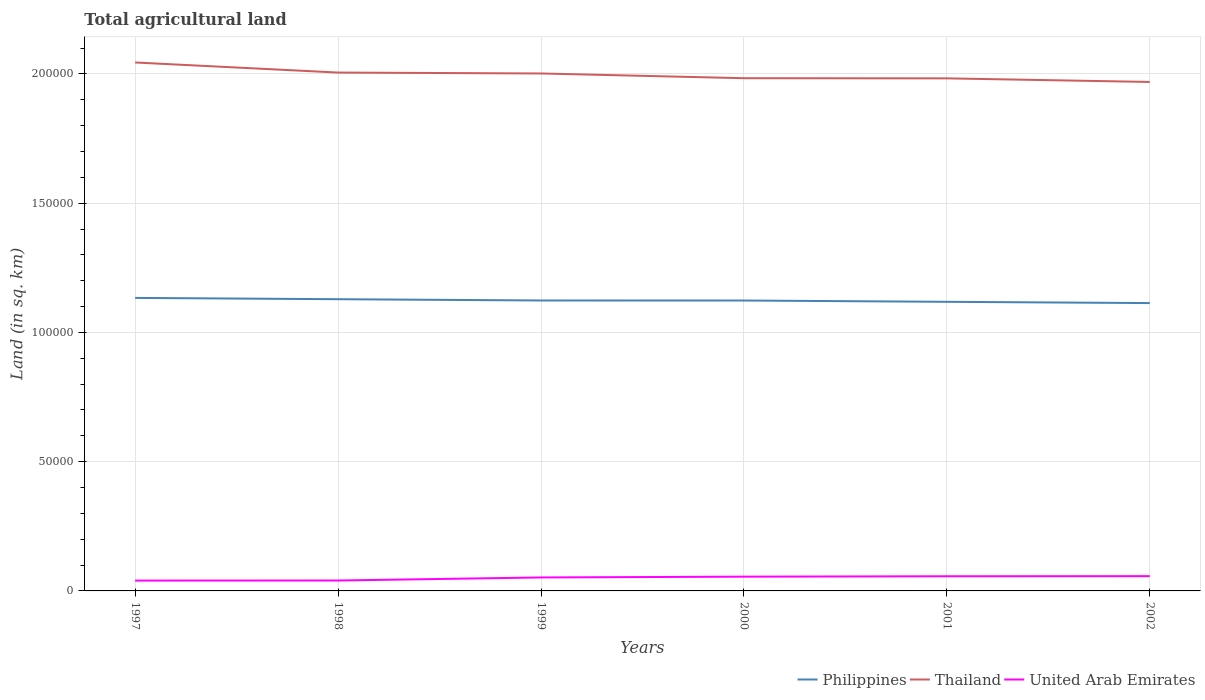How many different coloured lines are there?
Your response must be concise. 3. Does the line corresponding to Thailand intersect with the line corresponding to Philippines?
Provide a short and direct response. No. Across all years, what is the maximum total agricultural land in United Arab Emirates?
Keep it short and to the point. 4000. In which year was the total agricultural land in Thailand maximum?
Keep it short and to the point. 2002. What is the total total agricultural land in Philippines in the graph?
Keep it short and to the point. 10. What is the difference between the highest and the second highest total agricultural land in Thailand?
Offer a very short reply. 7530. What is the difference between the highest and the lowest total agricultural land in United Arab Emirates?
Offer a terse response. 4. Does the graph contain grids?
Ensure brevity in your answer.  Yes. How are the legend labels stacked?
Give a very brief answer. Horizontal. What is the title of the graph?
Provide a succinct answer. Total agricultural land. Does "Uganda" appear as one of the legend labels in the graph?
Give a very brief answer. No. What is the label or title of the X-axis?
Keep it short and to the point. Years. What is the label or title of the Y-axis?
Your answer should be very brief. Land (in sq. km). What is the Land (in sq. km) of Philippines in 1997?
Offer a terse response. 1.13e+05. What is the Land (in sq. km) of Thailand in 1997?
Your response must be concise. 2.04e+05. What is the Land (in sq. km) in United Arab Emirates in 1997?
Ensure brevity in your answer.  4000. What is the Land (in sq. km) in Philippines in 1998?
Make the answer very short. 1.13e+05. What is the Land (in sq. km) of Thailand in 1998?
Provide a short and direct response. 2.01e+05. What is the Land (in sq. km) in United Arab Emirates in 1998?
Keep it short and to the point. 4030. What is the Land (in sq. km) of Philippines in 1999?
Give a very brief answer. 1.12e+05. What is the Land (in sq. km) in Thailand in 1999?
Make the answer very short. 2.00e+05. What is the Land (in sq. km) of United Arab Emirates in 1999?
Offer a terse response. 5210. What is the Land (in sq. km) of Philippines in 2000?
Make the answer very short. 1.12e+05. What is the Land (in sq. km) in Thailand in 2000?
Ensure brevity in your answer.  1.98e+05. What is the Land (in sq. km) of United Arab Emirates in 2000?
Give a very brief answer. 5520. What is the Land (in sq. km) of Philippines in 2001?
Your response must be concise. 1.12e+05. What is the Land (in sq. km) of Thailand in 2001?
Make the answer very short. 1.98e+05. What is the Land (in sq. km) in United Arab Emirates in 2001?
Give a very brief answer. 5670. What is the Land (in sq. km) in Philippines in 2002?
Your answer should be very brief. 1.11e+05. What is the Land (in sq. km) in Thailand in 2002?
Keep it short and to the point. 1.97e+05. What is the Land (in sq. km) in United Arab Emirates in 2002?
Offer a very short reply. 5710. Across all years, what is the maximum Land (in sq. km) in Philippines?
Offer a very short reply. 1.13e+05. Across all years, what is the maximum Land (in sq. km) in Thailand?
Provide a succinct answer. 2.04e+05. Across all years, what is the maximum Land (in sq. km) in United Arab Emirates?
Keep it short and to the point. 5710. Across all years, what is the minimum Land (in sq. km) of Philippines?
Provide a short and direct response. 1.11e+05. Across all years, what is the minimum Land (in sq. km) in Thailand?
Your answer should be compact. 1.97e+05. Across all years, what is the minimum Land (in sq. km) in United Arab Emirates?
Offer a very short reply. 4000. What is the total Land (in sq. km) of Philippines in the graph?
Ensure brevity in your answer.  6.74e+05. What is the total Land (in sq. km) in Thailand in the graph?
Provide a succinct answer. 1.20e+06. What is the total Land (in sq. km) in United Arab Emirates in the graph?
Ensure brevity in your answer.  3.01e+04. What is the difference between the Land (in sq. km) of Philippines in 1997 and that in 1998?
Provide a short and direct response. 500. What is the difference between the Land (in sq. km) in Thailand in 1997 and that in 1998?
Offer a very short reply. 3900. What is the difference between the Land (in sq. km) of United Arab Emirates in 1997 and that in 1998?
Give a very brief answer. -30. What is the difference between the Land (in sq. km) of Thailand in 1997 and that in 1999?
Your answer should be compact. 4250. What is the difference between the Land (in sq. km) of United Arab Emirates in 1997 and that in 1999?
Give a very brief answer. -1210. What is the difference between the Land (in sq. km) of Philippines in 1997 and that in 2000?
Offer a very short reply. 1010. What is the difference between the Land (in sq. km) of Thailand in 1997 and that in 2000?
Offer a very short reply. 6080. What is the difference between the Land (in sq. km) in United Arab Emirates in 1997 and that in 2000?
Make the answer very short. -1520. What is the difference between the Land (in sq. km) of Philippines in 1997 and that in 2001?
Give a very brief answer. 1510. What is the difference between the Land (in sq. km) of Thailand in 1997 and that in 2001?
Provide a short and direct response. 6140. What is the difference between the Land (in sq. km) in United Arab Emirates in 1997 and that in 2001?
Offer a very short reply. -1670. What is the difference between the Land (in sq. km) of Thailand in 1997 and that in 2002?
Your answer should be compact. 7530. What is the difference between the Land (in sq. km) in United Arab Emirates in 1997 and that in 2002?
Offer a very short reply. -1710. What is the difference between the Land (in sq. km) in Thailand in 1998 and that in 1999?
Offer a terse response. 350. What is the difference between the Land (in sq. km) of United Arab Emirates in 1998 and that in 1999?
Keep it short and to the point. -1180. What is the difference between the Land (in sq. km) of Philippines in 1998 and that in 2000?
Ensure brevity in your answer.  510. What is the difference between the Land (in sq. km) of Thailand in 1998 and that in 2000?
Ensure brevity in your answer.  2180. What is the difference between the Land (in sq. km) of United Arab Emirates in 1998 and that in 2000?
Offer a very short reply. -1490. What is the difference between the Land (in sq. km) of Philippines in 1998 and that in 2001?
Provide a short and direct response. 1010. What is the difference between the Land (in sq. km) of Thailand in 1998 and that in 2001?
Your answer should be compact. 2240. What is the difference between the Land (in sq. km) of United Arab Emirates in 1998 and that in 2001?
Offer a very short reply. -1640. What is the difference between the Land (in sq. km) in Philippines in 1998 and that in 2002?
Your answer should be very brief. 1500. What is the difference between the Land (in sq. km) of Thailand in 1998 and that in 2002?
Offer a very short reply. 3630. What is the difference between the Land (in sq. km) of United Arab Emirates in 1998 and that in 2002?
Your response must be concise. -1680. What is the difference between the Land (in sq. km) in Thailand in 1999 and that in 2000?
Provide a short and direct response. 1830. What is the difference between the Land (in sq. km) of United Arab Emirates in 1999 and that in 2000?
Keep it short and to the point. -310. What is the difference between the Land (in sq. km) of Philippines in 1999 and that in 2001?
Your answer should be very brief. 510. What is the difference between the Land (in sq. km) in Thailand in 1999 and that in 2001?
Give a very brief answer. 1890. What is the difference between the Land (in sq. km) in United Arab Emirates in 1999 and that in 2001?
Offer a terse response. -460. What is the difference between the Land (in sq. km) of Philippines in 1999 and that in 2002?
Your response must be concise. 1000. What is the difference between the Land (in sq. km) of Thailand in 1999 and that in 2002?
Provide a short and direct response. 3280. What is the difference between the Land (in sq. km) of United Arab Emirates in 1999 and that in 2002?
Give a very brief answer. -500. What is the difference between the Land (in sq. km) in Philippines in 2000 and that in 2001?
Your response must be concise. 500. What is the difference between the Land (in sq. km) in United Arab Emirates in 2000 and that in 2001?
Your answer should be very brief. -150. What is the difference between the Land (in sq. km) of Philippines in 2000 and that in 2002?
Offer a very short reply. 990. What is the difference between the Land (in sq. km) of Thailand in 2000 and that in 2002?
Provide a succinct answer. 1450. What is the difference between the Land (in sq. km) of United Arab Emirates in 2000 and that in 2002?
Give a very brief answer. -190. What is the difference between the Land (in sq. km) of Philippines in 2001 and that in 2002?
Provide a succinct answer. 490. What is the difference between the Land (in sq. km) in Thailand in 2001 and that in 2002?
Give a very brief answer. 1390. What is the difference between the Land (in sq. km) of Philippines in 1997 and the Land (in sq. km) of Thailand in 1998?
Offer a very short reply. -8.72e+04. What is the difference between the Land (in sq. km) in Philippines in 1997 and the Land (in sq. km) in United Arab Emirates in 1998?
Offer a very short reply. 1.09e+05. What is the difference between the Land (in sq. km) in Thailand in 1997 and the Land (in sq. km) in United Arab Emirates in 1998?
Your answer should be compact. 2.00e+05. What is the difference between the Land (in sq. km) in Philippines in 1997 and the Land (in sq. km) in Thailand in 1999?
Give a very brief answer. -8.68e+04. What is the difference between the Land (in sq. km) of Philippines in 1997 and the Land (in sq. km) of United Arab Emirates in 1999?
Give a very brief answer. 1.08e+05. What is the difference between the Land (in sq. km) in Thailand in 1997 and the Land (in sq. km) in United Arab Emirates in 1999?
Keep it short and to the point. 1.99e+05. What is the difference between the Land (in sq. km) of Philippines in 1997 and the Land (in sq. km) of Thailand in 2000?
Give a very brief answer. -8.50e+04. What is the difference between the Land (in sq. km) of Philippines in 1997 and the Land (in sq. km) of United Arab Emirates in 2000?
Offer a very short reply. 1.08e+05. What is the difference between the Land (in sq. km) in Thailand in 1997 and the Land (in sq. km) in United Arab Emirates in 2000?
Your answer should be very brief. 1.99e+05. What is the difference between the Land (in sq. km) of Philippines in 1997 and the Land (in sq. km) of Thailand in 2001?
Make the answer very short. -8.49e+04. What is the difference between the Land (in sq. km) in Philippines in 1997 and the Land (in sq. km) in United Arab Emirates in 2001?
Make the answer very short. 1.08e+05. What is the difference between the Land (in sq. km) of Thailand in 1997 and the Land (in sq. km) of United Arab Emirates in 2001?
Offer a very short reply. 1.99e+05. What is the difference between the Land (in sq. km) in Philippines in 1997 and the Land (in sq. km) in Thailand in 2002?
Ensure brevity in your answer.  -8.35e+04. What is the difference between the Land (in sq. km) in Philippines in 1997 and the Land (in sq. km) in United Arab Emirates in 2002?
Offer a very short reply. 1.08e+05. What is the difference between the Land (in sq. km) in Thailand in 1997 and the Land (in sq. km) in United Arab Emirates in 2002?
Provide a succinct answer. 1.99e+05. What is the difference between the Land (in sq. km) of Philippines in 1998 and the Land (in sq. km) of Thailand in 1999?
Offer a very short reply. -8.73e+04. What is the difference between the Land (in sq. km) in Philippines in 1998 and the Land (in sq. km) in United Arab Emirates in 1999?
Your answer should be very brief. 1.08e+05. What is the difference between the Land (in sq. km) in Thailand in 1998 and the Land (in sq. km) in United Arab Emirates in 1999?
Provide a short and direct response. 1.95e+05. What is the difference between the Land (in sq. km) in Philippines in 1998 and the Land (in sq. km) in Thailand in 2000?
Make the answer very short. -8.55e+04. What is the difference between the Land (in sq. km) in Philippines in 1998 and the Land (in sq. km) in United Arab Emirates in 2000?
Your answer should be compact. 1.07e+05. What is the difference between the Land (in sq. km) in Thailand in 1998 and the Land (in sq. km) in United Arab Emirates in 2000?
Make the answer very short. 1.95e+05. What is the difference between the Land (in sq. km) of Philippines in 1998 and the Land (in sq. km) of Thailand in 2001?
Your answer should be compact. -8.54e+04. What is the difference between the Land (in sq. km) in Philippines in 1998 and the Land (in sq. km) in United Arab Emirates in 2001?
Give a very brief answer. 1.07e+05. What is the difference between the Land (in sq. km) in Thailand in 1998 and the Land (in sq. km) in United Arab Emirates in 2001?
Your response must be concise. 1.95e+05. What is the difference between the Land (in sq. km) in Philippines in 1998 and the Land (in sq. km) in Thailand in 2002?
Your response must be concise. -8.40e+04. What is the difference between the Land (in sq. km) in Philippines in 1998 and the Land (in sq. km) in United Arab Emirates in 2002?
Offer a very short reply. 1.07e+05. What is the difference between the Land (in sq. km) of Thailand in 1998 and the Land (in sq. km) of United Arab Emirates in 2002?
Your answer should be compact. 1.95e+05. What is the difference between the Land (in sq. km) in Philippines in 1999 and the Land (in sq. km) in Thailand in 2000?
Give a very brief answer. -8.60e+04. What is the difference between the Land (in sq. km) of Philippines in 1999 and the Land (in sq. km) of United Arab Emirates in 2000?
Offer a very short reply. 1.07e+05. What is the difference between the Land (in sq. km) of Thailand in 1999 and the Land (in sq. km) of United Arab Emirates in 2000?
Provide a succinct answer. 1.95e+05. What is the difference between the Land (in sq. km) in Philippines in 1999 and the Land (in sq. km) in Thailand in 2001?
Provide a succinct answer. -8.59e+04. What is the difference between the Land (in sq. km) of Philippines in 1999 and the Land (in sq. km) of United Arab Emirates in 2001?
Give a very brief answer. 1.07e+05. What is the difference between the Land (in sq. km) in Thailand in 1999 and the Land (in sq. km) in United Arab Emirates in 2001?
Provide a succinct answer. 1.94e+05. What is the difference between the Land (in sq. km) in Philippines in 1999 and the Land (in sq. km) in Thailand in 2002?
Your response must be concise. -8.45e+04. What is the difference between the Land (in sq. km) in Philippines in 1999 and the Land (in sq. km) in United Arab Emirates in 2002?
Keep it short and to the point. 1.07e+05. What is the difference between the Land (in sq. km) of Thailand in 1999 and the Land (in sq. km) of United Arab Emirates in 2002?
Keep it short and to the point. 1.94e+05. What is the difference between the Land (in sq. km) of Philippines in 2000 and the Land (in sq. km) of Thailand in 2001?
Give a very brief answer. -8.59e+04. What is the difference between the Land (in sq. km) of Philippines in 2000 and the Land (in sq. km) of United Arab Emirates in 2001?
Your response must be concise. 1.07e+05. What is the difference between the Land (in sq. km) of Thailand in 2000 and the Land (in sq. km) of United Arab Emirates in 2001?
Provide a short and direct response. 1.93e+05. What is the difference between the Land (in sq. km) of Philippines in 2000 and the Land (in sq. km) of Thailand in 2002?
Provide a succinct answer. -8.46e+04. What is the difference between the Land (in sq. km) in Philippines in 2000 and the Land (in sq. km) in United Arab Emirates in 2002?
Ensure brevity in your answer.  1.07e+05. What is the difference between the Land (in sq. km) of Thailand in 2000 and the Land (in sq. km) of United Arab Emirates in 2002?
Offer a very short reply. 1.93e+05. What is the difference between the Land (in sq. km) of Philippines in 2001 and the Land (in sq. km) of Thailand in 2002?
Your answer should be very brief. -8.50e+04. What is the difference between the Land (in sq. km) in Philippines in 2001 and the Land (in sq. km) in United Arab Emirates in 2002?
Your response must be concise. 1.06e+05. What is the difference between the Land (in sq. km) in Thailand in 2001 and the Land (in sq. km) in United Arab Emirates in 2002?
Keep it short and to the point. 1.93e+05. What is the average Land (in sq. km) of Philippines per year?
Offer a terse response. 1.12e+05. What is the average Land (in sq. km) in Thailand per year?
Your answer should be very brief. 2.00e+05. What is the average Land (in sq. km) in United Arab Emirates per year?
Ensure brevity in your answer.  5023.33. In the year 1997, what is the difference between the Land (in sq. km) in Philippines and Land (in sq. km) in Thailand?
Ensure brevity in your answer.  -9.11e+04. In the year 1997, what is the difference between the Land (in sq. km) in Philippines and Land (in sq. km) in United Arab Emirates?
Your response must be concise. 1.09e+05. In the year 1997, what is the difference between the Land (in sq. km) of Thailand and Land (in sq. km) of United Arab Emirates?
Ensure brevity in your answer.  2.00e+05. In the year 1998, what is the difference between the Land (in sq. km) in Philippines and Land (in sq. km) in Thailand?
Make the answer very short. -8.77e+04. In the year 1998, what is the difference between the Land (in sq. km) of Philippines and Land (in sq. km) of United Arab Emirates?
Provide a short and direct response. 1.09e+05. In the year 1998, what is the difference between the Land (in sq. km) of Thailand and Land (in sq. km) of United Arab Emirates?
Keep it short and to the point. 1.96e+05. In the year 1999, what is the difference between the Land (in sq. km) in Philippines and Land (in sq. km) in Thailand?
Your response must be concise. -8.78e+04. In the year 1999, what is the difference between the Land (in sq. km) of Philippines and Land (in sq. km) of United Arab Emirates?
Provide a succinct answer. 1.07e+05. In the year 1999, what is the difference between the Land (in sq. km) in Thailand and Land (in sq. km) in United Arab Emirates?
Your answer should be very brief. 1.95e+05. In the year 2000, what is the difference between the Land (in sq. km) of Philippines and Land (in sq. km) of Thailand?
Provide a succinct answer. -8.60e+04. In the year 2000, what is the difference between the Land (in sq. km) in Philippines and Land (in sq. km) in United Arab Emirates?
Keep it short and to the point. 1.07e+05. In the year 2000, what is the difference between the Land (in sq. km) in Thailand and Land (in sq. km) in United Arab Emirates?
Offer a terse response. 1.93e+05. In the year 2001, what is the difference between the Land (in sq. km) in Philippines and Land (in sq. km) in Thailand?
Provide a succinct answer. -8.64e+04. In the year 2001, what is the difference between the Land (in sq. km) in Philippines and Land (in sq. km) in United Arab Emirates?
Provide a short and direct response. 1.06e+05. In the year 2001, what is the difference between the Land (in sq. km) of Thailand and Land (in sq. km) of United Arab Emirates?
Give a very brief answer. 1.93e+05. In the year 2002, what is the difference between the Land (in sq. km) of Philippines and Land (in sq. km) of Thailand?
Your response must be concise. -8.55e+04. In the year 2002, what is the difference between the Land (in sq. km) of Philippines and Land (in sq. km) of United Arab Emirates?
Provide a succinct answer. 1.06e+05. In the year 2002, what is the difference between the Land (in sq. km) in Thailand and Land (in sq. km) in United Arab Emirates?
Your answer should be very brief. 1.91e+05. What is the ratio of the Land (in sq. km) of Philippines in 1997 to that in 1998?
Give a very brief answer. 1. What is the ratio of the Land (in sq. km) of Thailand in 1997 to that in 1998?
Make the answer very short. 1.02. What is the ratio of the Land (in sq. km) of United Arab Emirates in 1997 to that in 1998?
Your response must be concise. 0.99. What is the ratio of the Land (in sq. km) of Philippines in 1997 to that in 1999?
Your response must be concise. 1.01. What is the ratio of the Land (in sq. km) of Thailand in 1997 to that in 1999?
Provide a succinct answer. 1.02. What is the ratio of the Land (in sq. km) in United Arab Emirates in 1997 to that in 1999?
Offer a very short reply. 0.77. What is the ratio of the Land (in sq. km) in Thailand in 1997 to that in 2000?
Your response must be concise. 1.03. What is the ratio of the Land (in sq. km) in United Arab Emirates in 1997 to that in 2000?
Your answer should be compact. 0.72. What is the ratio of the Land (in sq. km) in Philippines in 1997 to that in 2001?
Provide a succinct answer. 1.01. What is the ratio of the Land (in sq. km) of Thailand in 1997 to that in 2001?
Provide a short and direct response. 1.03. What is the ratio of the Land (in sq. km) in United Arab Emirates in 1997 to that in 2001?
Your response must be concise. 0.71. What is the ratio of the Land (in sq. km) of Thailand in 1997 to that in 2002?
Your answer should be very brief. 1.04. What is the ratio of the Land (in sq. km) of United Arab Emirates in 1997 to that in 2002?
Make the answer very short. 0.7. What is the ratio of the Land (in sq. km) of Thailand in 1998 to that in 1999?
Offer a terse response. 1. What is the ratio of the Land (in sq. km) of United Arab Emirates in 1998 to that in 1999?
Your response must be concise. 0.77. What is the ratio of the Land (in sq. km) of Thailand in 1998 to that in 2000?
Keep it short and to the point. 1.01. What is the ratio of the Land (in sq. km) in United Arab Emirates in 1998 to that in 2000?
Keep it short and to the point. 0.73. What is the ratio of the Land (in sq. km) in Philippines in 1998 to that in 2001?
Provide a short and direct response. 1.01. What is the ratio of the Land (in sq. km) in Thailand in 1998 to that in 2001?
Your answer should be compact. 1.01. What is the ratio of the Land (in sq. km) of United Arab Emirates in 1998 to that in 2001?
Provide a succinct answer. 0.71. What is the ratio of the Land (in sq. km) of Philippines in 1998 to that in 2002?
Provide a short and direct response. 1.01. What is the ratio of the Land (in sq. km) in Thailand in 1998 to that in 2002?
Provide a succinct answer. 1.02. What is the ratio of the Land (in sq. km) of United Arab Emirates in 1998 to that in 2002?
Ensure brevity in your answer.  0.71. What is the ratio of the Land (in sq. km) of Philippines in 1999 to that in 2000?
Give a very brief answer. 1. What is the ratio of the Land (in sq. km) in Thailand in 1999 to that in 2000?
Ensure brevity in your answer.  1.01. What is the ratio of the Land (in sq. km) in United Arab Emirates in 1999 to that in 2000?
Provide a succinct answer. 0.94. What is the ratio of the Land (in sq. km) of Philippines in 1999 to that in 2001?
Your response must be concise. 1. What is the ratio of the Land (in sq. km) of Thailand in 1999 to that in 2001?
Keep it short and to the point. 1.01. What is the ratio of the Land (in sq. km) in United Arab Emirates in 1999 to that in 2001?
Offer a terse response. 0.92. What is the ratio of the Land (in sq. km) in Philippines in 1999 to that in 2002?
Offer a terse response. 1.01. What is the ratio of the Land (in sq. km) in Thailand in 1999 to that in 2002?
Keep it short and to the point. 1.02. What is the ratio of the Land (in sq. km) in United Arab Emirates in 1999 to that in 2002?
Provide a short and direct response. 0.91. What is the ratio of the Land (in sq. km) in United Arab Emirates in 2000 to that in 2001?
Provide a succinct answer. 0.97. What is the ratio of the Land (in sq. km) in Philippines in 2000 to that in 2002?
Offer a very short reply. 1.01. What is the ratio of the Land (in sq. km) in Thailand in 2000 to that in 2002?
Offer a terse response. 1.01. What is the ratio of the Land (in sq. km) in United Arab Emirates in 2000 to that in 2002?
Your response must be concise. 0.97. What is the ratio of the Land (in sq. km) of Philippines in 2001 to that in 2002?
Offer a very short reply. 1. What is the ratio of the Land (in sq. km) of Thailand in 2001 to that in 2002?
Offer a very short reply. 1.01. What is the difference between the highest and the second highest Land (in sq. km) of Philippines?
Your answer should be very brief. 500. What is the difference between the highest and the second highest Land (in sq. km) of Thailand?
Ensure brevity in your answer.  3900. What is the difference between the highest and the second highest Land (in sq. km) in United Arab Emirates?
Give a very brief answer. 40. What is the difference between the highest and the lowest Land (in sq. km) in Philippines?
Give a very brief answer. 2000. What is the difference between the highest and the lowest Land (in sq. km) in Thailand?
Give a very brief answer. 7530. What is the difference between the highest and the lowest Land (in sq. km) of United Arab Emirates?
Ensure brevity in your answer.  1710. 